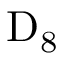Convert formula to latex. <formula><loc_0><loc_0><loc_500><loc_500>D _ { 8 }</formula> 